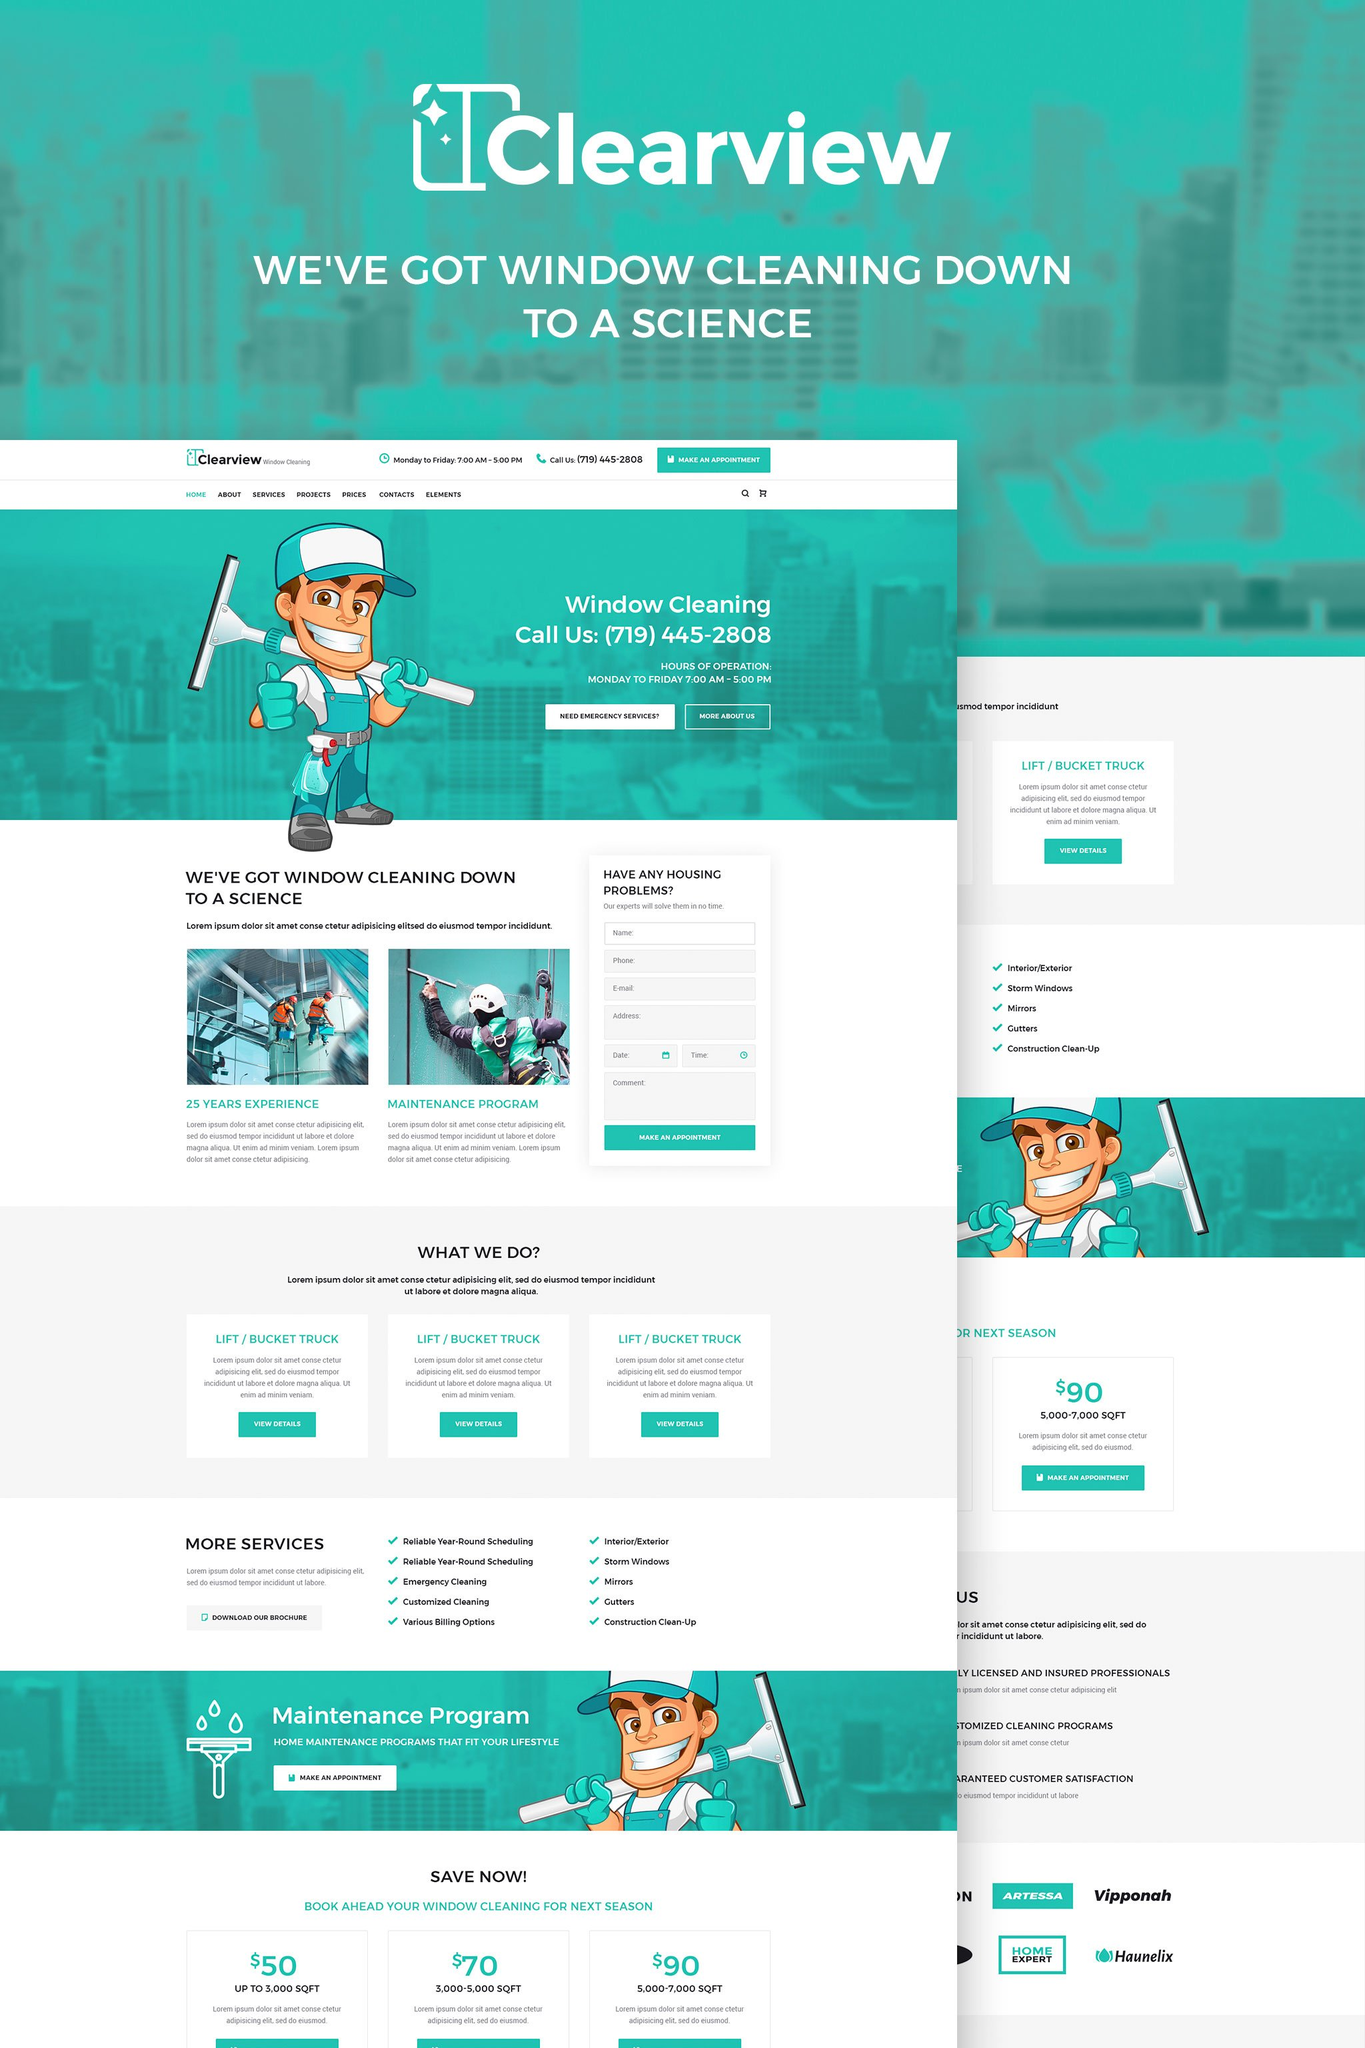What are the key footer elements that enhance user experience as found on Clearview's homepage? The footer of Clearview's homepage includes several elements that enhance user experience. These include contact information, quick links to services, and social media icons, which provide easy navigation and multiple channels for communication. It also features a newsletter signup form, which keeps customers informed and engaged with upcoming deals and services. 